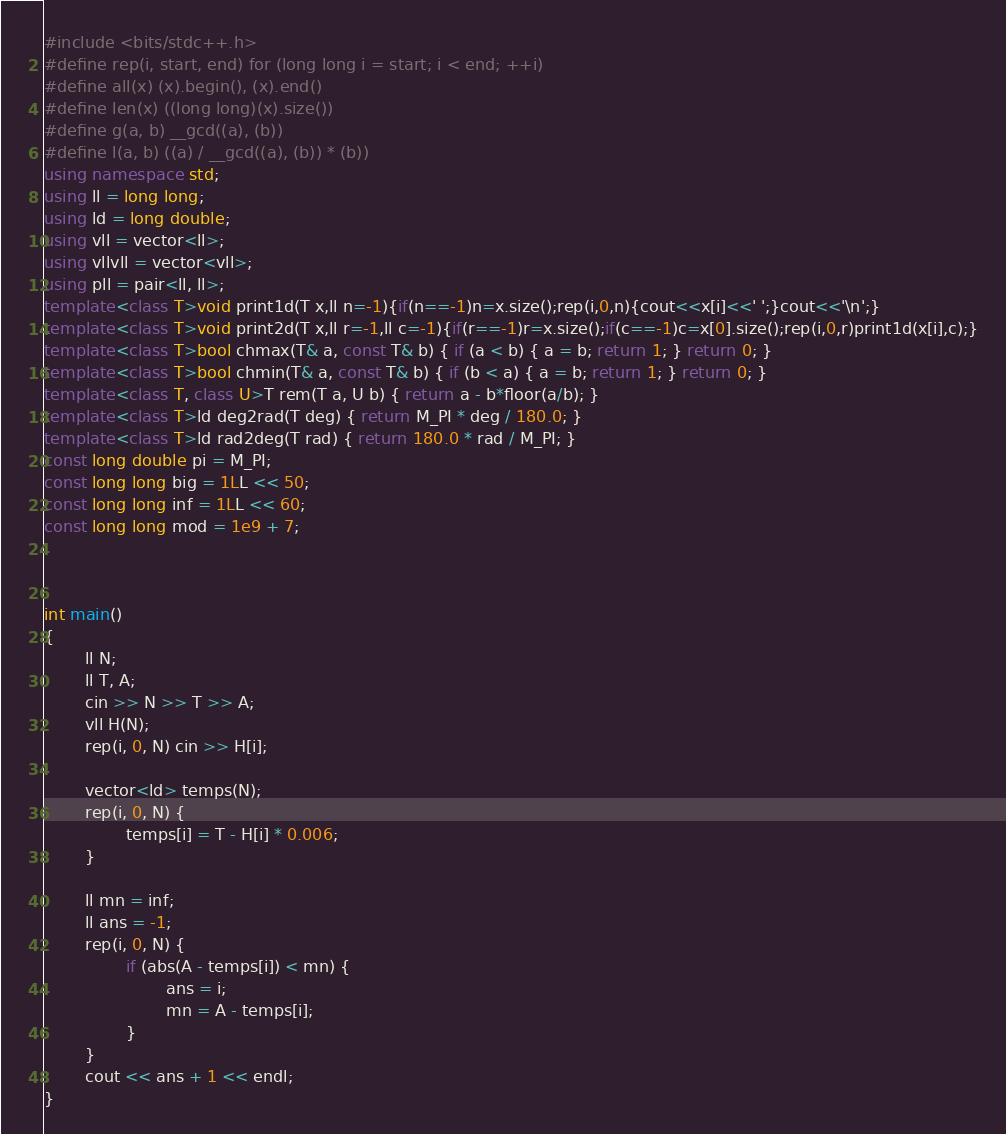Convert code to text. <code><loc_0><loc_0><loc_500><loc_500><_C++_>#include <bits/stdc++.h>
#define rep(i, start, end) for (long long i = start; i < end; ++i)
#define all(x) (x).begin(), (x).end()
#define len(x) ((long long)(x).size())
#define g(a, b) __gcd((a), (b))
#define l(a, b) ((a) / __gcd((a), (b)) * (b))
using namespace std;
using ll = long long;
using ld = long double;
using vll = vector<ll>;
using vllvll = vector<vll>;
using pll = pair<ll, ll>;
template<class T>void print1d(T x,ll n=-1){if(n==-1)n=x.size();rep(i,0,n){cout<<x[i]<<' ';}cout<<'\n';}
template<class T>void print2d(T x,ll r=-1,ll c=-1){if(r==-1)r=x.size();if(c==-1)c=x[0].size();rep(i,0,r)print1d(x[i],c);}
template<class T>bool chmax(T& a, const T& b) { if (a < b) { a = b; return 1; } return 0; }
template<class T>bool chmin(T& a, const T& b) { if (b < a) { a = b; return 1; } return 0; }
template<class T, class U>T rem(T a, U b) { return a - b*floor(a/b); }
template<class T>ld deg2rad(T deg) { return M_PI * deg / 180.0; }
template<class T>ld rad2deg(T rad) { return 180.0 * rad / M_PI; }
const long double pi = M_PI;
const long long big = 1LL << 50;
const long long inf = 1LL << 60;
const long long mod = 1e9 + 7;



int main()
{
        ll N;
        ll T, A;
        cin >> N >> T >> A;
        vll H(N);
        rep(i, 0, N) cin >> H[i];

        vector<ld> temps(N);
        rep(i, 0, N) {
                temps[i] = T - H[i] * 0.006;
        }

        ll mn = inf;
        ll ans = -1;
        rep(i, 0, N) {
                if (abs(A - temps[i]) < mn) {
                        ans = i;
                        mn = A - temps[i];
                }
        } 
        cout << ans + 1 << endl;
}</code> 